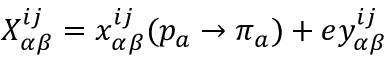<formula> <loc_0><loc_0><loc_500><loc_500>X _ { \alpha \beta } ^ { i j } = x _ { \alpha \beta } ^ { i j } ( p _ { a } \rightarrow \pi _ { a } ) + e y _ { \alpha \beta } ^ { i j }</formula> 